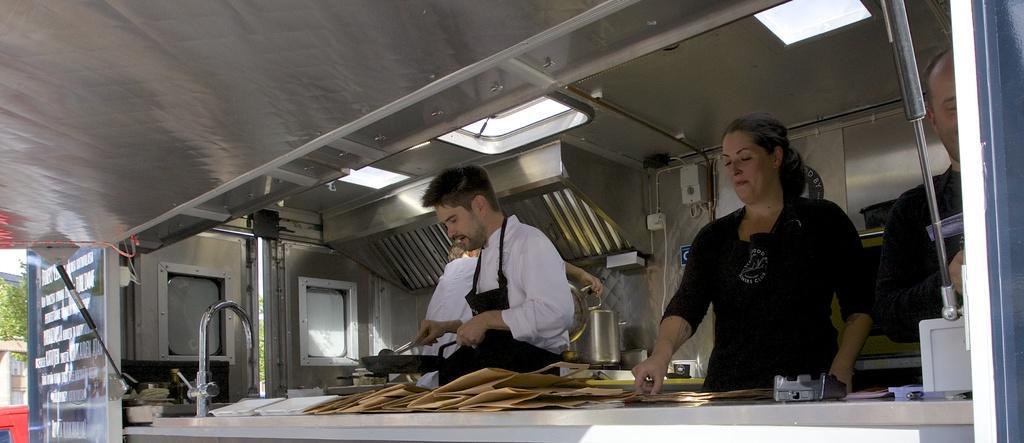Describe this image in one or two sentences. In this image I can see group of people standing. In front the person is wearing white and black color dress and holding some object. In front I can see the pan and few objects and I can also see the tap. In the background I can see few plants in green color and the sky is in white color. 